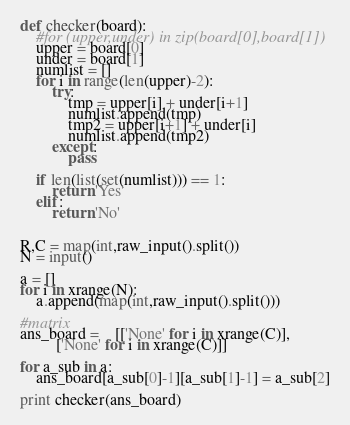Convert code to text. <code><loc_0><loc_0><loc_500><loc_500><_Python_>def checker(board):
    #for (upper,under) in zip(board[0],board[1])
    upper = board[0]
    under = board[1]
    numlist = []
    for i in range(len(upper)-2):
        try:
            tmp = upper[i] + under[i+1]
            numlist.append(tmp)
            tmp2 = upper[i+1] + under[i]
            numlist.append(tmp2)
        except:
            pass

    if len(list(set(numlist))) == 1:
        return 'Yes'
    elif:
        return 'No'


R,C = map(int,raw_input().split())
N = input()

a = []
for i in xrange(N):
    a.append(map(int,raw_input().split()))

#matrix
ans_board =	[['None' for i in xrange(C)],
         ['None' for i in xrange(C)]]

for a_sub in a:
    ans_board[a_sub[0]-1][a_sub[1]-1] = a_sub[2]

print checker(ans_board)</code> 